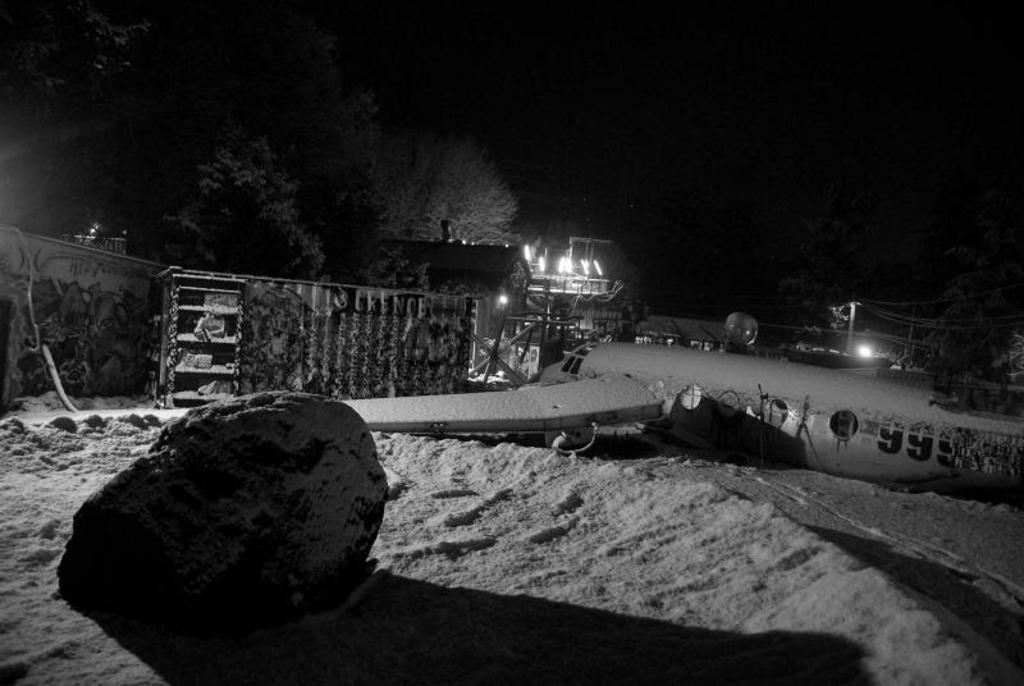What is the color scheme of the image? The image is in black and white. What type of natural elements can be seen in the image? There are rocks and trees in the image. What type of man-made structures are present in the image? There is a wall, a house, wires, poles, and lights in the image. What is the condition of the sky in the background? The sky in the background is dark. What type of calendar is hanging on the wall in the image? There is no calendar present in the image; it only features a wall, rocks, trees, wires, poles, lights, and a dark sky in the background. How comfortable are the rocks in the image? The question of comfort does not apply to rocks, as they are inanimate objects and cannot experience comfort. 